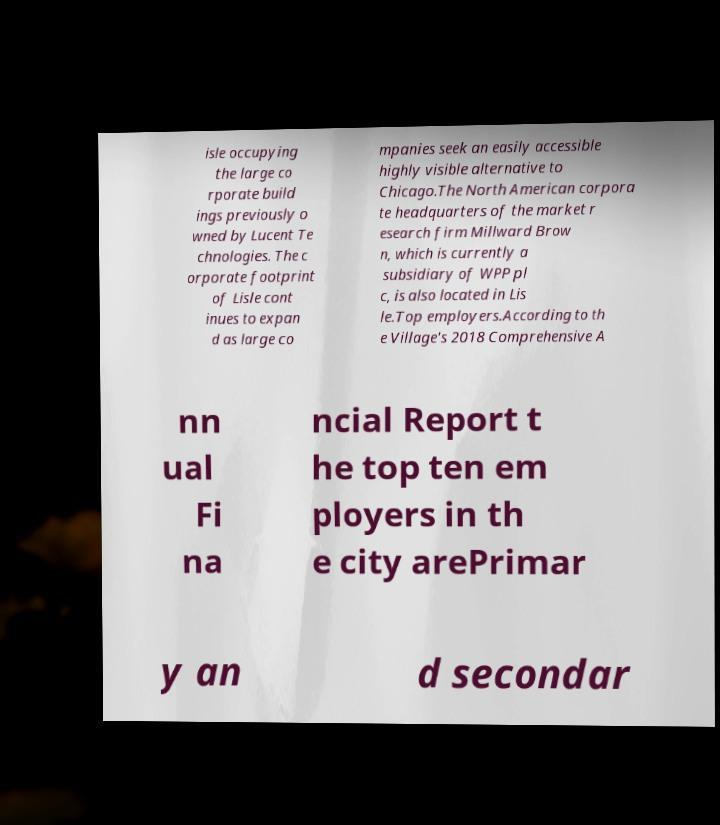Please read and relay the text visible in this image. What does it say? isle occupying the large co rporate build ings previously o wned by Lucent Te chnologies. The c orporate footprint of Lisle cont inues to expan d as large co mpanies seek an easily accessible highly visible alternative to Chicago.The North American corpora te headquarters of the market r esearch firm Millward Brow n, which is currently a subsidiary of WPP pl c, is also located in Lis le.Top employers.According to th e Village's 2018 Comprehensive A nn ual Fi na ncial Report t he top ten em ployers in th e city arePrimar y an d secondar 